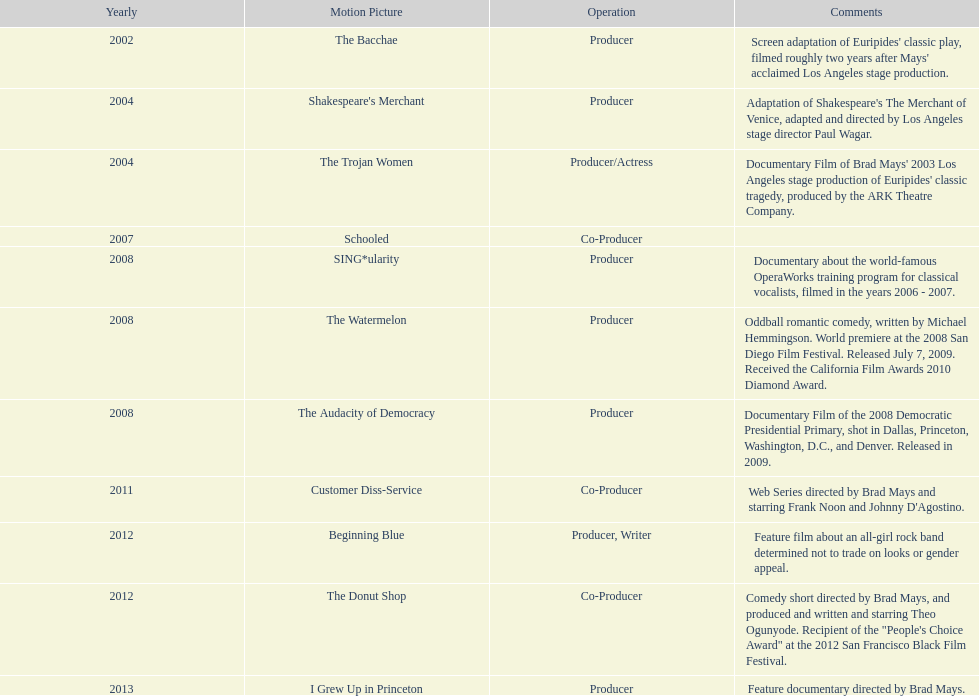How many years before was the film bacchae out before the watermelon? 6. 